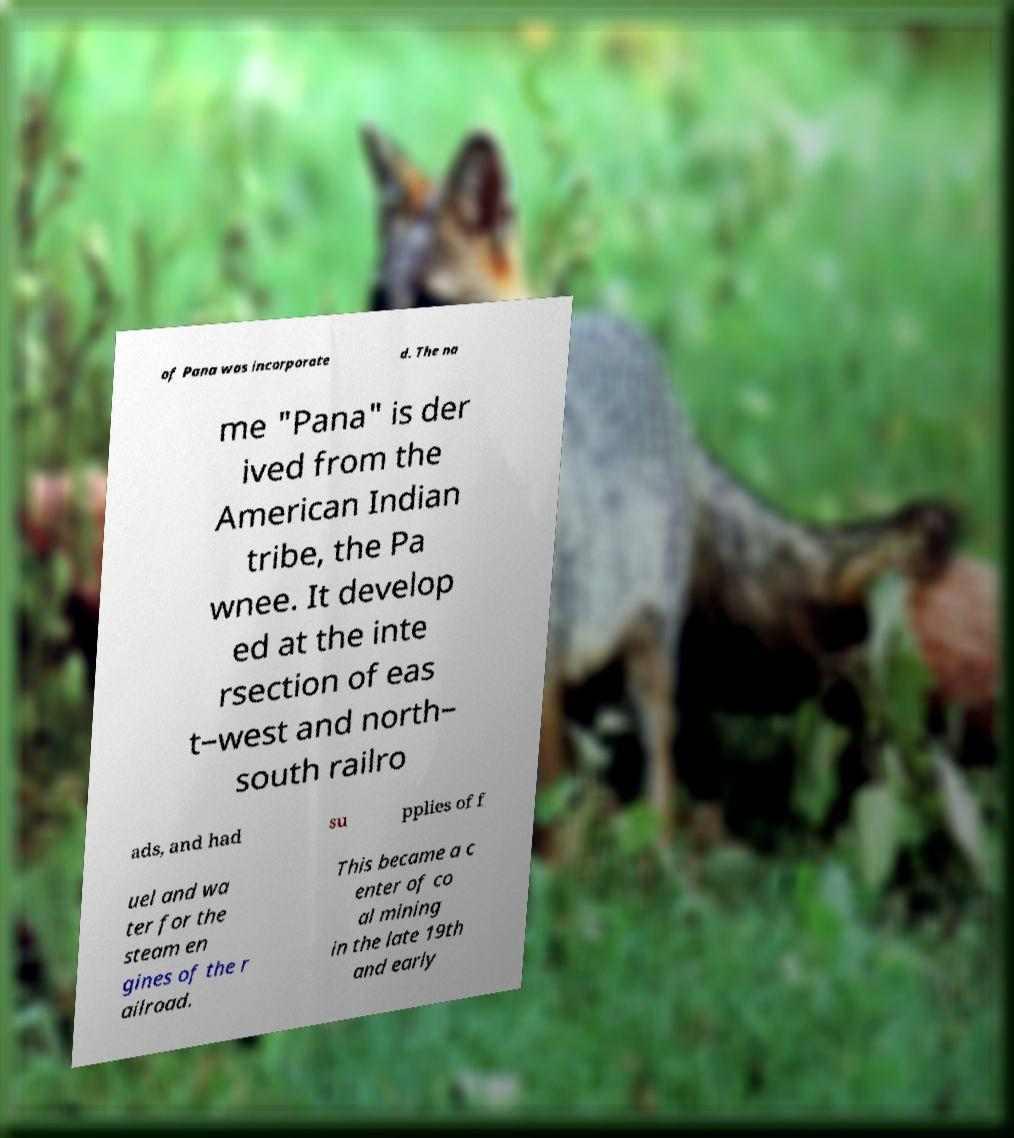Can you read and provide the text displayed in the image?This photo seems to have some interesting text. Can you extract and type it out for me? of Pana was incorporate d. The na me "Pana" is der ived from the American Indian tribe, the Pa wnee. It develop ed at the inte rsection of eas t–west and north– south railro ads, and had su pplies of f uel and wa ter for the steam en gines of the r ailroad. This became a c enter of co al mining in the late 19th and early 